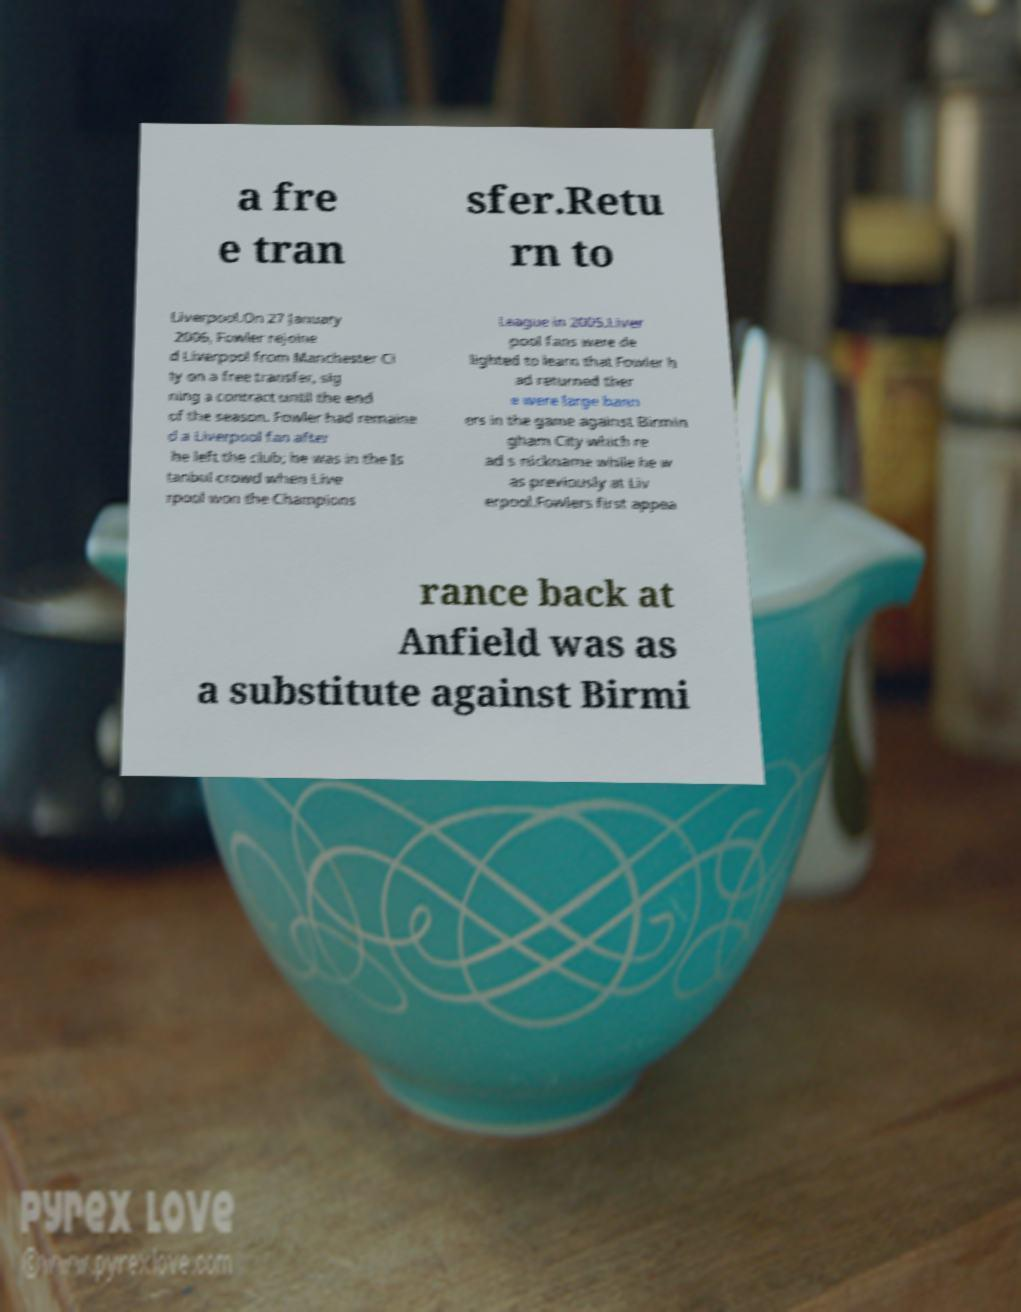There's text embedded in this image that I need extracted. Can you transcribe it verbatim? a fre e tran sfer.Retu rn to Liverpool.On 27 January 2006, Fowler rejoine d Liverpool from Manchester Ci ty on a free transfer, sig ning a contract until the end of the season. Fowler had remaine d a Liverpool fan after he left the club; he was in the Is tanbul crowd when Live rpool won the Champions League in 2005.Liver pool fans were de lighted to learn that Fowler h ad returned ther e were large bann ers in the game against Birmin gham City which re ad s nickname while he w as previously at Liv erpool.Fowlers first appea rance back at Anfield was as a substitute against Birmi 